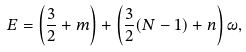<formula> <loc_0><loc_0><loc_500><loc_500>E = \left ( \frac { 3 } { 2 } + m \right ) + \left ( \frac { 3 } { 2 } ( N - 1 ) + n \right ) \omega ,</formula> 